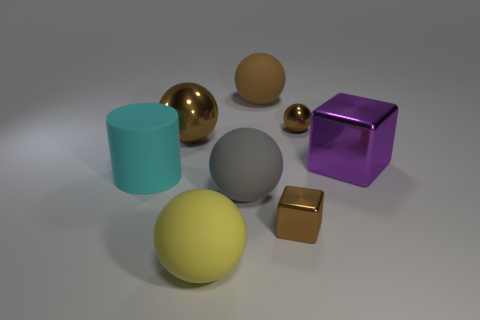Subtract all brown blocks. How many brown spheres are left? 3 Subtract all brown blocks. Subtract all yellow cylinders. How many blocks are left? 1 Add 2 small green metallic spheres. How many objects exist? 10 Subtract all spheres. How many objects are left? 3 Add 2 tiny brown things. How many tiny brown things are left? 4 Add 6 tiny yellow metal things. How many tiny yellow metal things exist? 6 Subtract 1 brown balls. How many objects are left? 7 Subtract all tiny green cylinders. Subtract all blocks. How many objects are left? 6 